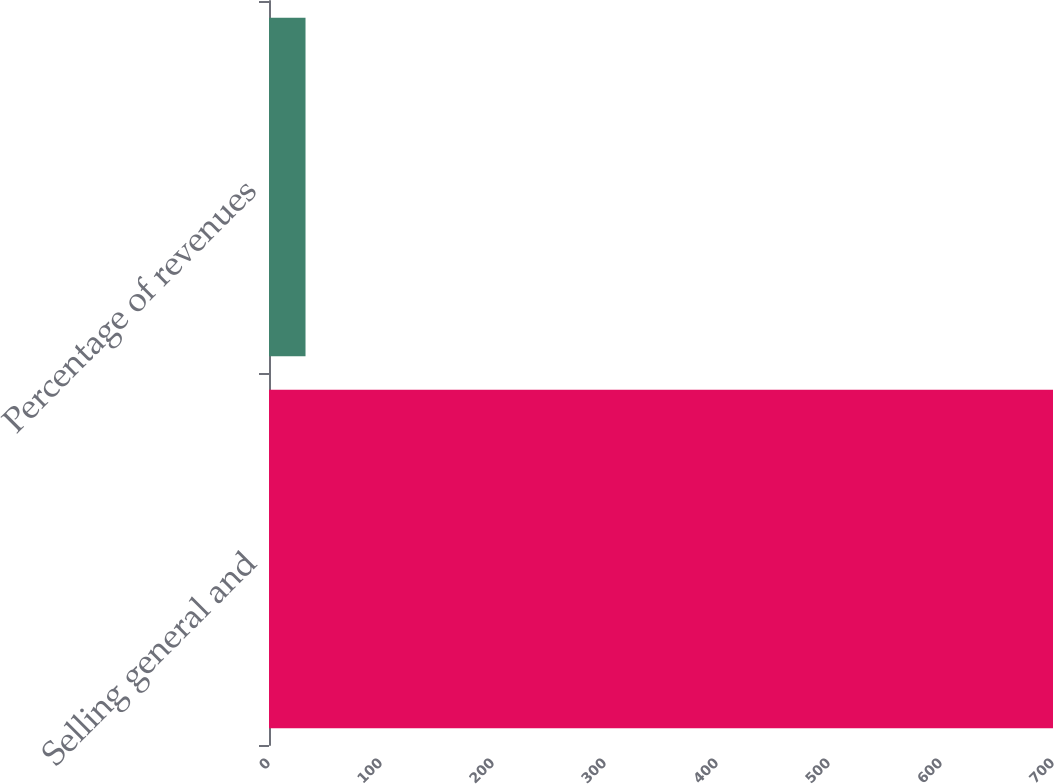Convert chart to OTSL. <chart><loc_0><loc_0><loc_500><loc_500><bar_chart><fcel>Selling general and<fcel>Percentage of revenues<nl><fcel>700<fcel>32.6<nl></chart> 